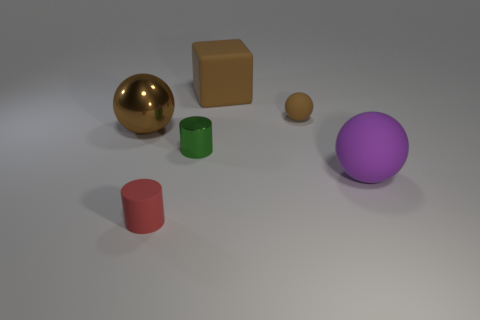Are the brown ball that is right of the big brown matte thing and the brown sphere that is to the left of the green thing made of the same material?
Your response must be concise. No. Are there any purple cubes of the same size as the purple sphere?
Your answer should be very brief. No. What size is the brown thing in front of the tiny rubber object right of the brown cube?
Your response must be concise. Large. How many small balls have the same color as the metal cylinder?
Give a very brief answer. 0. What is the shape of the big rubber object that is on the right side of the brown ball to the right of the green metallic cylinder?
Provide a succinct answer. Sphere. What number of big blocks are made of the same material as the tiny brown thing?
Give a very brief answer. 1. What is the tiny thing that is in front of the purple rubber sphere made of?
Offer a very short reply. Rubber. There is a tiny green thing behind the large rubber thing that is in front of the big object on the left side of the green metal cylinder; what shape is it?
Keep it short and to the point. Cylinder. There is a rubber thing behind the tiny rubber ball; is it the same color as the small rubber thing that is right of the large brown rubber object?
Offer a very short reply. Yes. Is the number of big purple spheres right of the purple matte sphere less than the number of rubber spheres in front of the green cylinder?
Provide a short and direct response. Yes. 